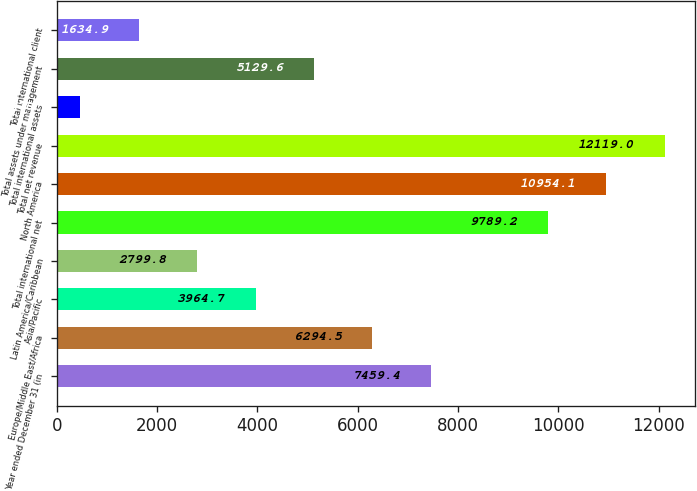<chart> <loc_0><loc_0><loc_500><loc_500><bar_chart><fcel>Year ended December 31 (in<fcel>Europe/Middle East/Africa<fcel>Asia/Pacific<fcel>Latin America/Caribbean<fcel>Total international net<fcel>North America<fcel>Total net revenue<fcel>Total international assets<fcel>Total assets under management<fcel>Total international client<nl><fcel>7459.4<fcel>6294.5<fcel>3964.7<fcel>2799.8<fcel>9789.2<fcel>10954.1<fcel>12119<fcel>470<fcel>5129.6<fcel>1634.9<nl></chart> 